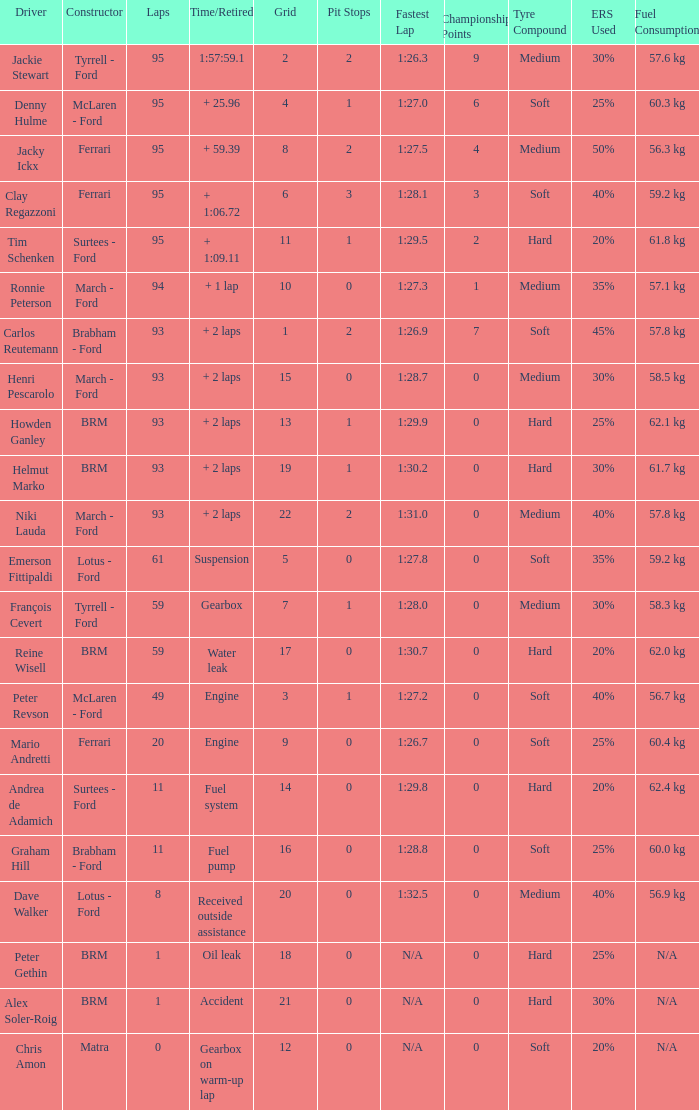What is the largest number of laps with a Grid larger than 14, a Time/Retired of + 2 laps, and a Driver of helmut marko? 93.0. Can you parse all the data within this table? {'header': ['Driver', 'Constructor', 'Laps', 'Time/Retired', 'Grid', 'Pit Stops', 'Fastest Lap', 'Championship Points', 'Tyre Compound', 'ERS Used', 'Fuel Consumption'], 'rows': [['Jackie Stewart', 'Tyrrell - Ford', '95', '1:57:59.1', '2', '2', '1:26.3', '9', 'Medium', '30%', '57.6 kg'], ['Denny Hulme', 'McLaren - Ford', '95', '+ 25.96', '4', '1', '1:27.0', '6', 'Soft', '25%', '60.3 kg'], ['Jacky Ickx', 'Ferrari', '95', '+ 59.39', '8', '2', '1:27.5', '4', 'Medium', '50%', '56.3 kg'], ['Clay Regazzoni', 'Ferrari', '95', '+ 1:06.72', '6', '3', '1:28.1', '3', 'Soft', '40%', '59.2 kg'], ['Tim Schenken', 'Surtees - Ford', '95', '+ 1:09.11', '11', '1', '1:29.5', '2', 'Hard', '20%', '61.8 kg'], ['Ronnie Peterson', 'March - Ford', '94', '+ 1 lap', '10', '0', '1:27.3', '1', 'Medium', '35%', '57.1 kg'], ['Carlos Reutemann', 'Brabham - Ford', '93', '+ 2 laps', '1', '2', '1:26.9', '7', 'Soft', '45%', '57.8 kg'], ['Henri Pescarolo', 'March - Ford', '93', '+ 2 laps', '15', '0', '1:28.7', '0', 'Medium', '30%', '58.5 kg'], ['Howden Ganley', 'BRM', '93', '+ 2 laps', '13', '1', '1:29.9', '0', 'Hard', '25%', '62.1 kg'], ['Helmut Marko', 'BRM', '93', '+ 2 laps', '19', '1', '1:30.2', '0', 'Hard', '30%', '61.7 kg'], ['Niki Lauda', 'March - Ford', '93', '+ 2 laps', '22', '2', '1:31.0', '0', 'Medium', '40%', '57.8 kg'], ['Emerson Fittipaldi', 'Lotus - Ford', '61', 'Suspension', '5', '0', '1:27.8', '0', 'Soft', '35%', '59.2 kg'], ['François Cevert', 'Tyrrell - Ford', '59', 'Gearbox', '7', '1', '1:28.0', '0', 'Medium', '30%', '58.3 kg'], ['Reine Wisell', 'BRM', '59', 'Water leak', '17', '0', '1:30.7', '0', 'Hard', '20%', '62.0 kg'], ['Peter Revson', 'McLaren - Ford', '49', 'Engine', '3', '1', '1:27.2', '0', 'Soft', '40%', '56.7 kg'], ['Mario Andretti', 'Ferrari', '20', 'Engine', '9', '0', '1:26.7', '0', 'Soft', '25%', '60.4 kg'], ['Andrea de Adamich', 'Surtees - Ford', '11', 'Fuel system', '14', '0', '1:29.8', '0', 'Hard', '20%', '62.4 kg'], ['Graham Hill', 'Brabham - Ford', '11', 'Fuel pump', '16', '0', '1:28.8', '0', 'Soft', '25%', '60.0 kg'], ['Dave Walker', 'Lotus - Ford', '8', 'Received outside assistance', '20', '0', '1:32.5', '0', 'Medium', '40%', '56.9 kg'], ['Peter Gethin', 'BRM', '1', 'Oil leak', '18', '0', 'N/A', '0', 'Hard', '25%', 'N/A'], ['Alex Soler-Roig', 'BRM', '1', 'Accident', '21', '0', 'N/A', '0', 'Hard', '30%', 'N/A'], ['Chris Amon', 'Matra', '0', 'Gearbox on warm-up lap', '12', '0', 'N/A', '0', 'Soft', '20%', 'N/A']]} 